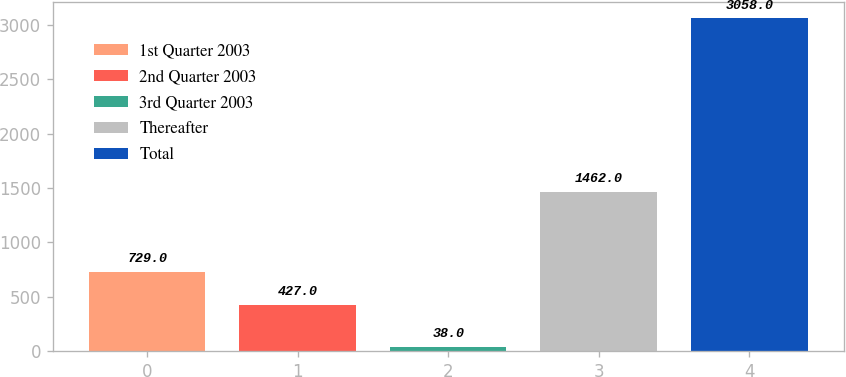<chart> <loc_0><loc_0><loc_500><loc_500><bar_chart><fcel>1st Quarter 2003<fcel>2nd Quarter 2003<fcel>3rd Quarter 2003<fcel>Thereafter<fcel>Total<nl><fcel>729<fcel>427<fcel>38<fcel>1462<fcel>3058<nl></chart> 